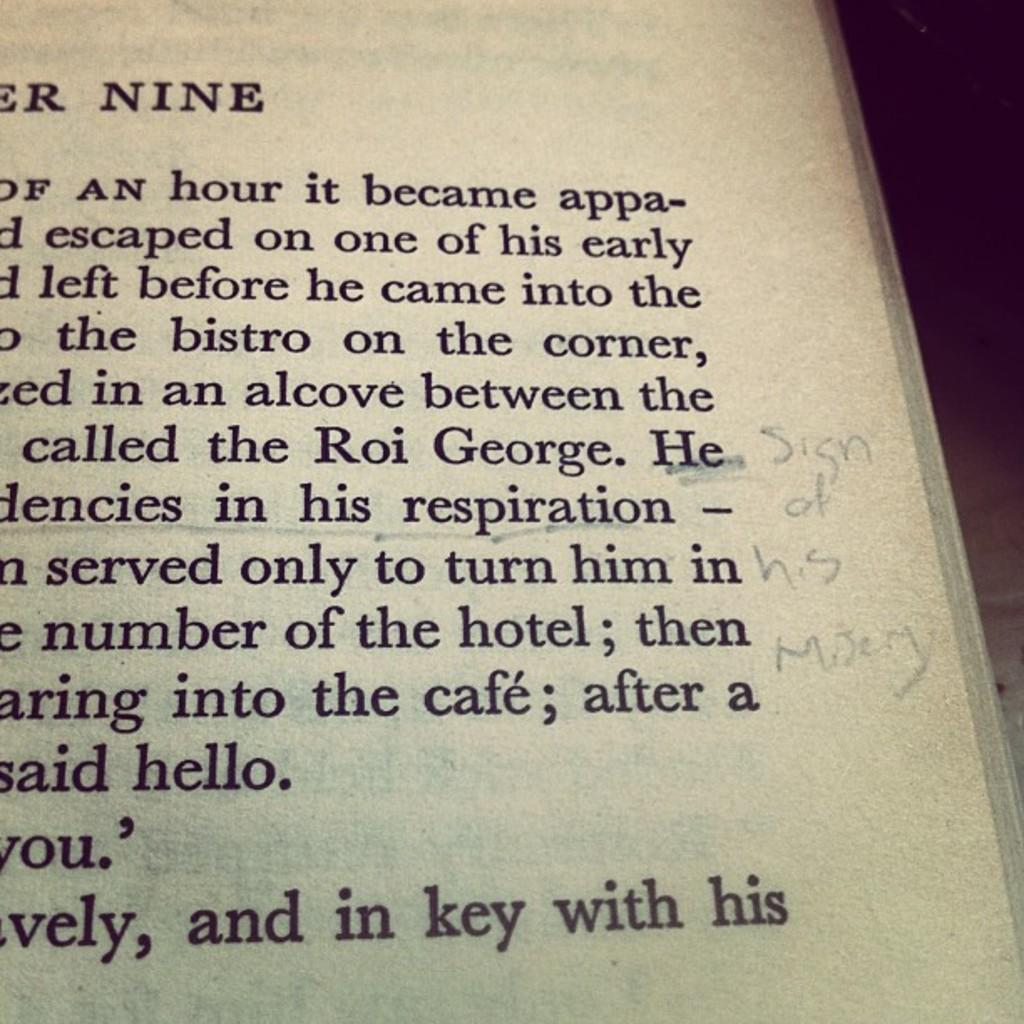Provide a one-sentence caption for the provided image. The corner of a book page with the writings 'Sign of his misery.'. 